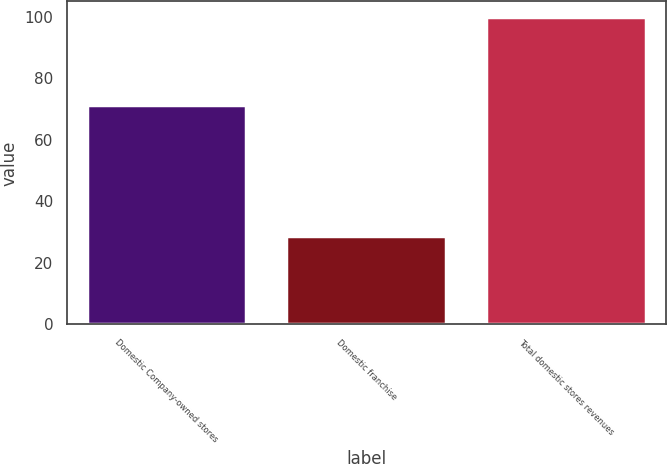<chart> <loc_0><loc_0><loc_500><loc_500><bar_chart><fcel>Domestic Company-owned stores<fcel>Domestic franchise<fcel>Total domestic stores revenues<nl><fcel>71.2<fcel>28.8<fcel>100<nl></chart> 